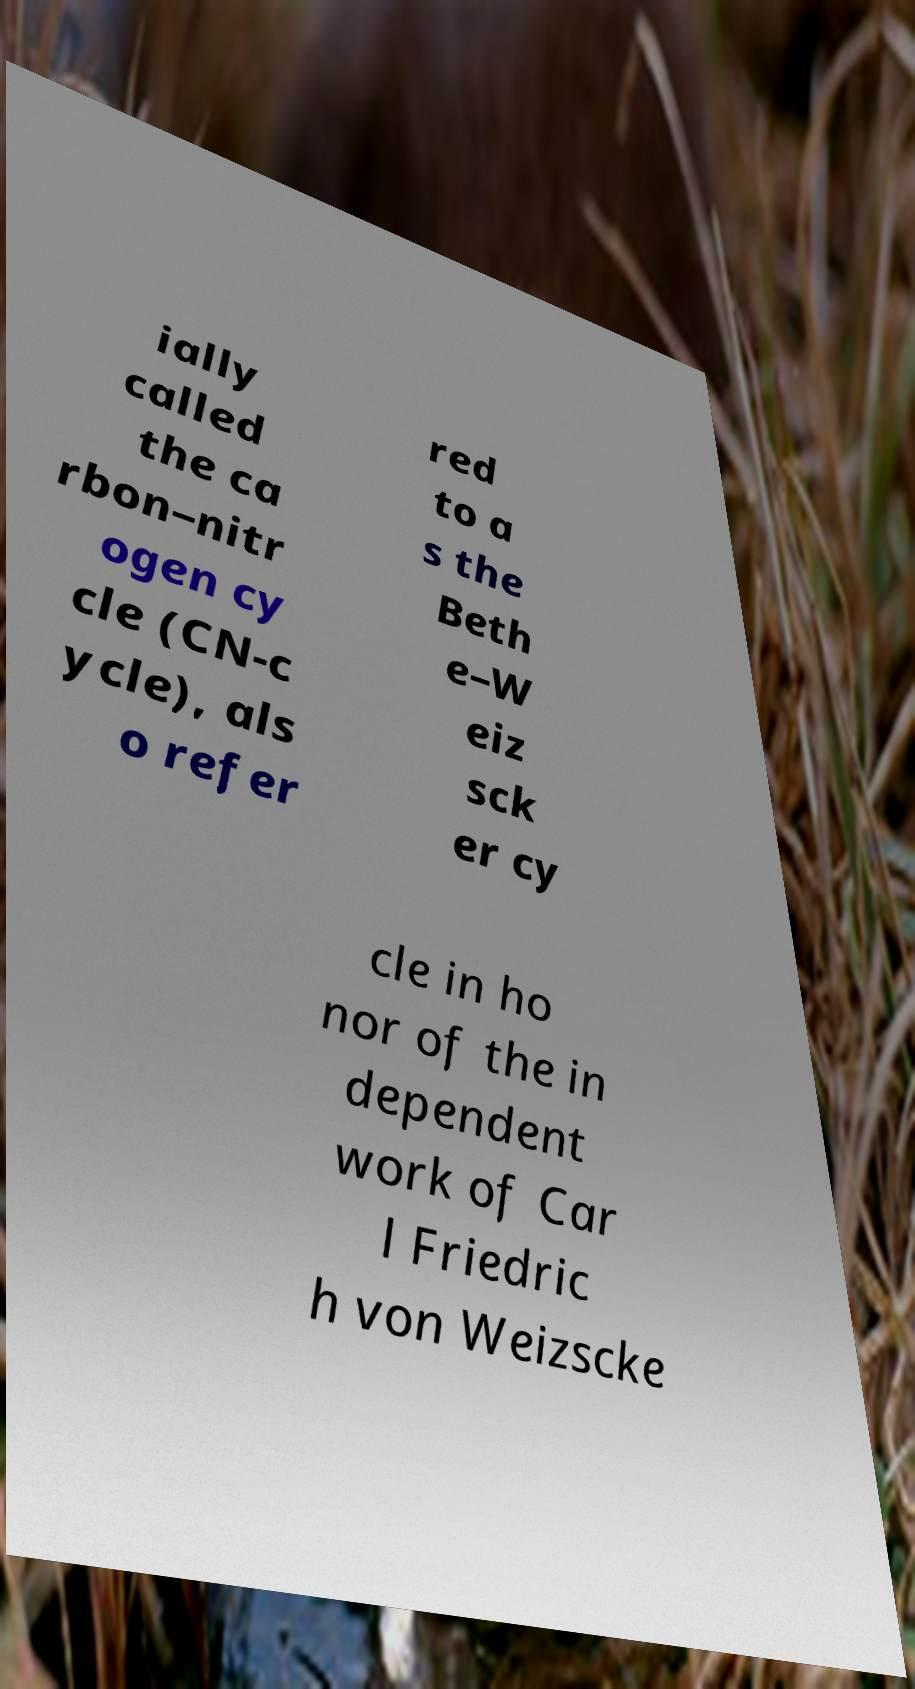Could you assist in decoding the text presented in this image and type it out clearly? ially called the ca rbon–nitr ogen cy cle (CN-c ycle), als o refer red to a s the Beth e–W eiz sck er cy cle in ho nor of the in dependent work of Car l Friedric h von Weizscke 